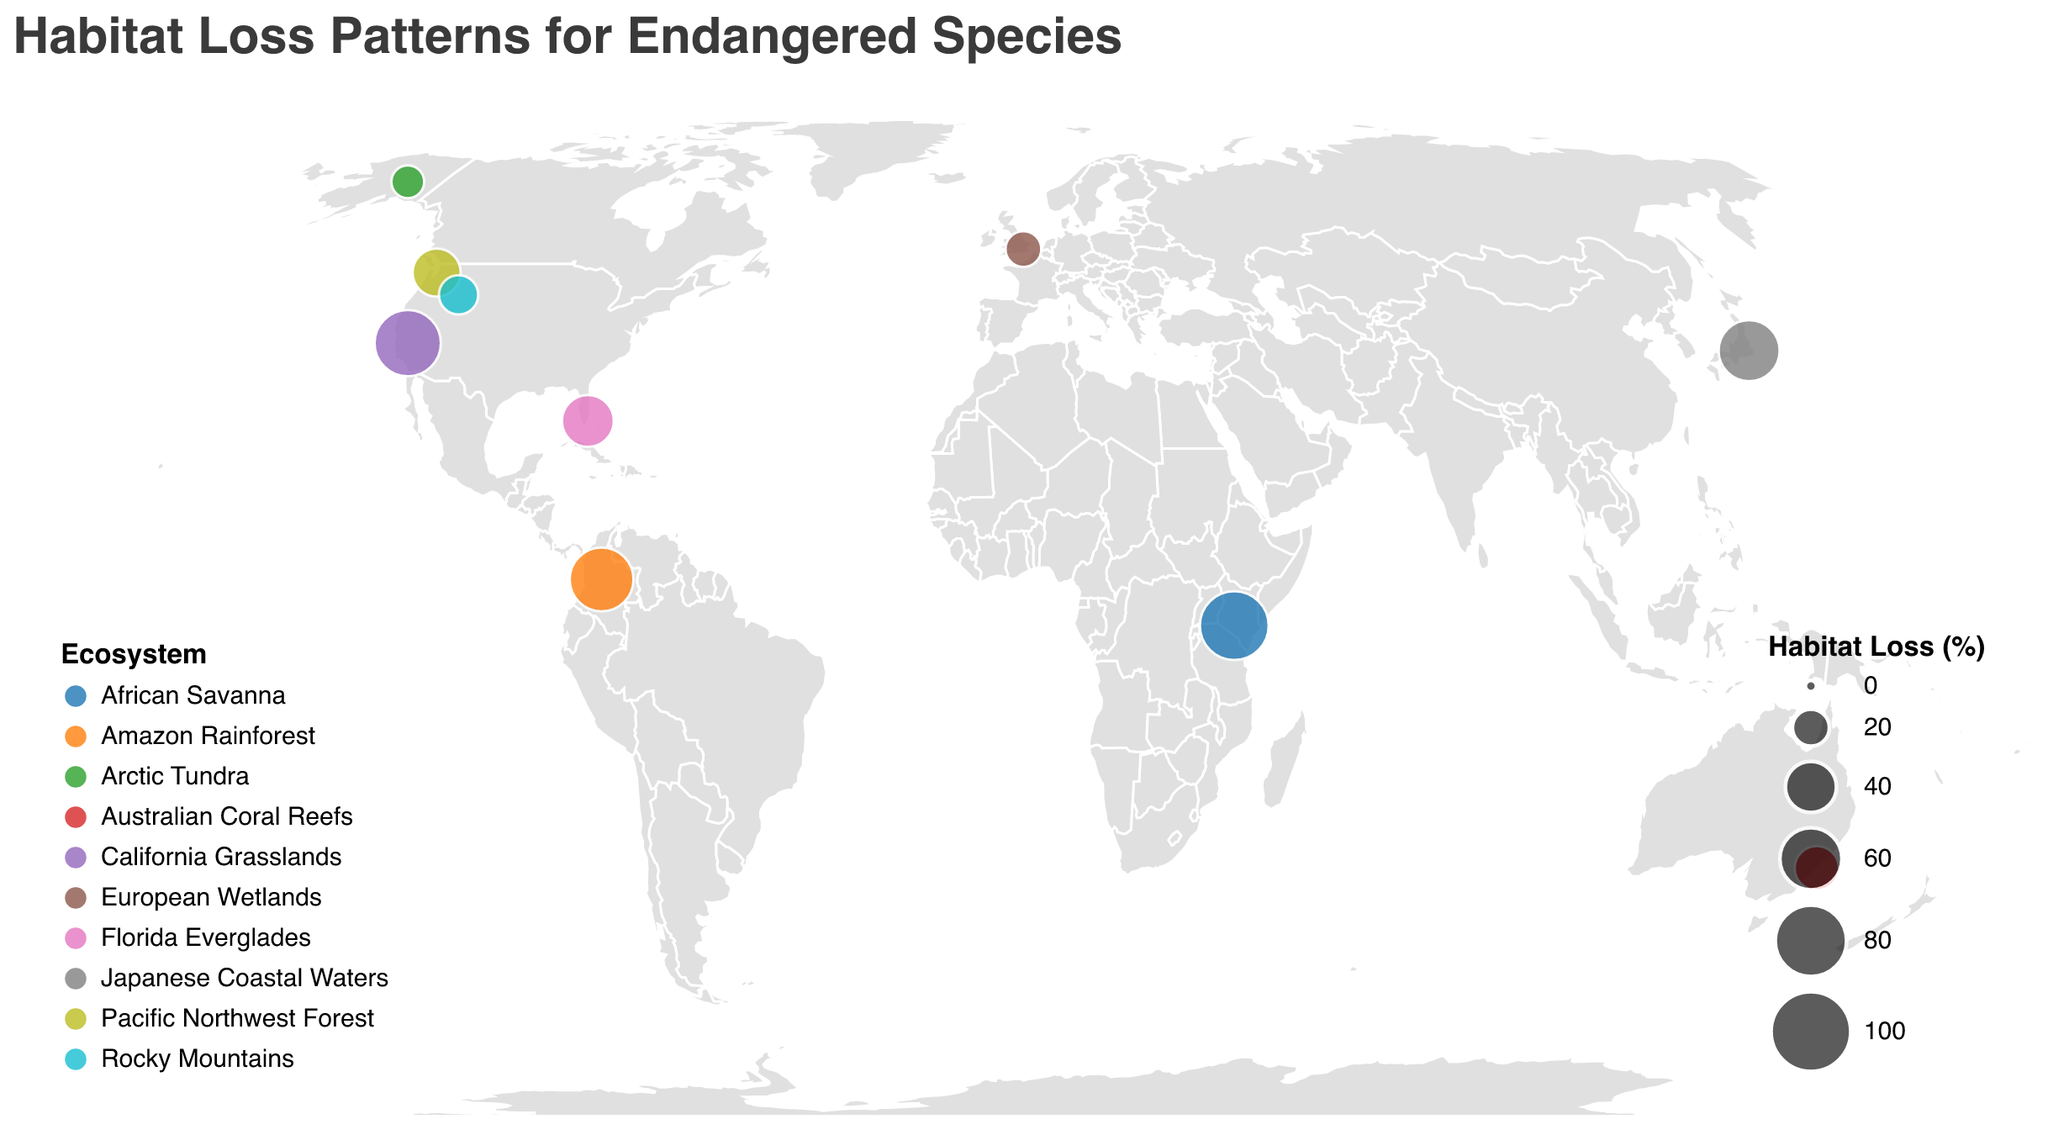What is the habitat loss percentage for the Black Rhino in the African Savanna? Locate the point on the map corresponding to the African Savanna and read the value associated with the Black Rhino.
Answer: 74.1% Which species has the lowest habitat loss percentage? Identify the point with the smallest circle size and read the species from the tooltip. The Arctic Tundra point shows the Polar Bear with the lowest habitat loss.
Answer: Polar Bear Compare the habitat loss between the California Grasslands and Amazon Rainforest ecosystems? Compare the circle sizes for these two ecosystems. The tooltip shows California Grasslands (68.7%) and Amazon Rainforest (63.5%). The California Grasslands has a higher habitat loss than the Amazon Rainforest.
Answer: California Grasslands What's the average habitat loss percentage for species in North America (Pacific Northwest Forest, California Grasslands, Florida Everglades, Rocky Mountains)? Sum the habitat loss percentages for the species in North America (35.2 + 68.7 + 41.3 + 22.8) and divide by the number of species (4). The average is (35.2 + 68.7 + 41.3 + 22.8) / 4 = 42.0%.
Answer: 42.0% Which ecosystem shows the greatest habitat loss for its species? Identify the ecosystem with the largest circle size. The African Savanna with the Black Rhino shows the highest habitat loss at 74.1%.
Answer: African Savanna How many ecosystems on the map have a habitat loss percentage of over 50%? Identify and count the number of circles with a tooltip showing habitat loss percentages greater than 50%. The ecosystems are California Grasslands (68.7%), Japanese Coastal Waters (57.9%), African Savanna (74.1%), and Amazon Rainforest (63.5%). There are four ecosystems.
Answer: 4 What is the size of the circle on the map that represents the Grizzly Bear in the Rocky Mountains? Find the circle representing the Rocky Mountains and match it to the Grizzly Bear. The habitat loss percentage for the Grizzly Bear is 22.8%.
Answer: 22.8% Which species can be found in the European Wetlands? Locate the point on the map for European Wetlands and read the species from the tooltip. The species listed is the European Otter.
Answer: European Otter Which ecosystem has a habitat loss percentage closest to the mid-point (50%) value? Identify the ecosystem with a habitat loss percentage closest to 50% by comparing the values. The closest value to 50% is Japanese Coastal Waters with a habitat loss percentage of 57.9%.
Answer: Japanese Coastal Waters 